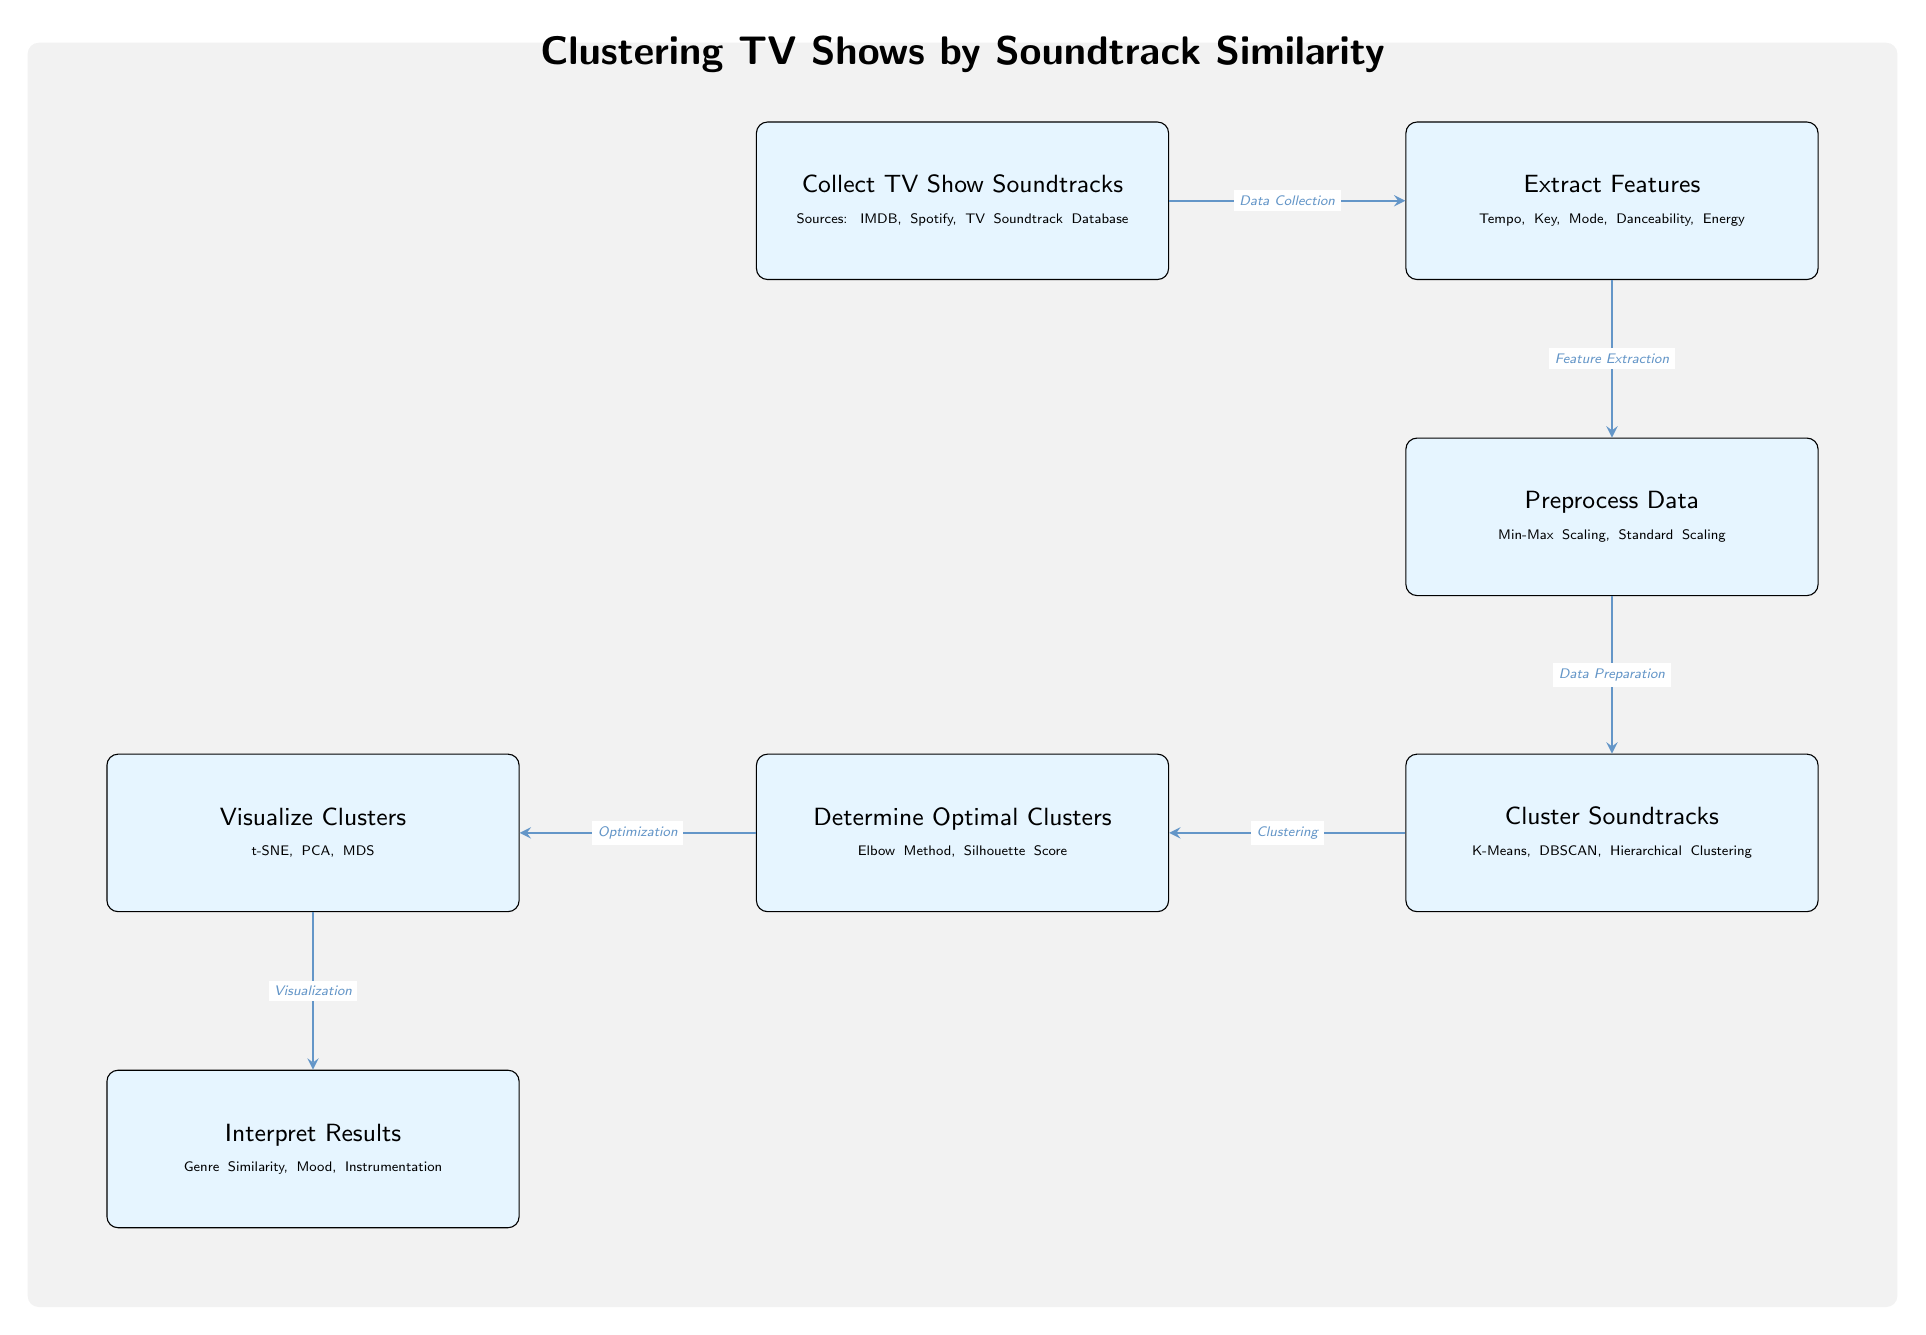What is the first step in the diagram? The first step is to "Collect TV Show Soundtracks" which is indicated at the top of the diagram.
Answer: Collect TV Show Soundtracks How many clustering methods are mentioned in the diagram? The diagram mentions three clustering methods: K-Means, DBSCAN, and Hierarchical Clustering, which are listed in the "Cluster Soundtracks" node.
Answer: Three What follows the data preprocessing step? The step that follows "Preprocess Data" is "Cluster Soundtracks," as shown directly below it in the diagram.
Answer: Cluster Soundtracks What is used to determine the optimal clusters? "Determine Optimal Clusters" utilizes the "Elbow Method" and "Silhouette Score," which are indicated in that node of the diagram.
Answer: Elbow Method, Silhouette Score What is the purpose of visualizing clusters? The purpose is to "Interpret Results," which is indicated at the bottom of the diagram as the final step following visualization.
Answer: Interpret Results What type of clustering is shown in the diagram? The diagram illustrates Unsupervised Learning, particularly focused on clustering techniques used for analyzing soundtracks.
Answer: Unsupervised Learning What key factors are extracted from the soundtracks? The key factors include "Tempo, Key, Mode, Danceability, Energy," which are listed under the node "Extract Features."
Answer: Tempo, Key, Mode, Danceability, Energy Which step involves data preparation? The step involved in data preparation is "Preprocess Data," which connects the extraction of features to the clustering phase.
Answer: Preprocess Data What is the last step in the process? The last step in the process is "Interpret Results," as shown in the bottom node of the diagram.
Answer: Interpret Results 